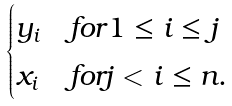<formula> <loc_0><loc_0><loc_500><loc_500>\begin{cases} y _ { i } & f o r 1 \leq i \leq j \\ x _ { i } & f o r j < i \leq n . \end{cases}</formula> 